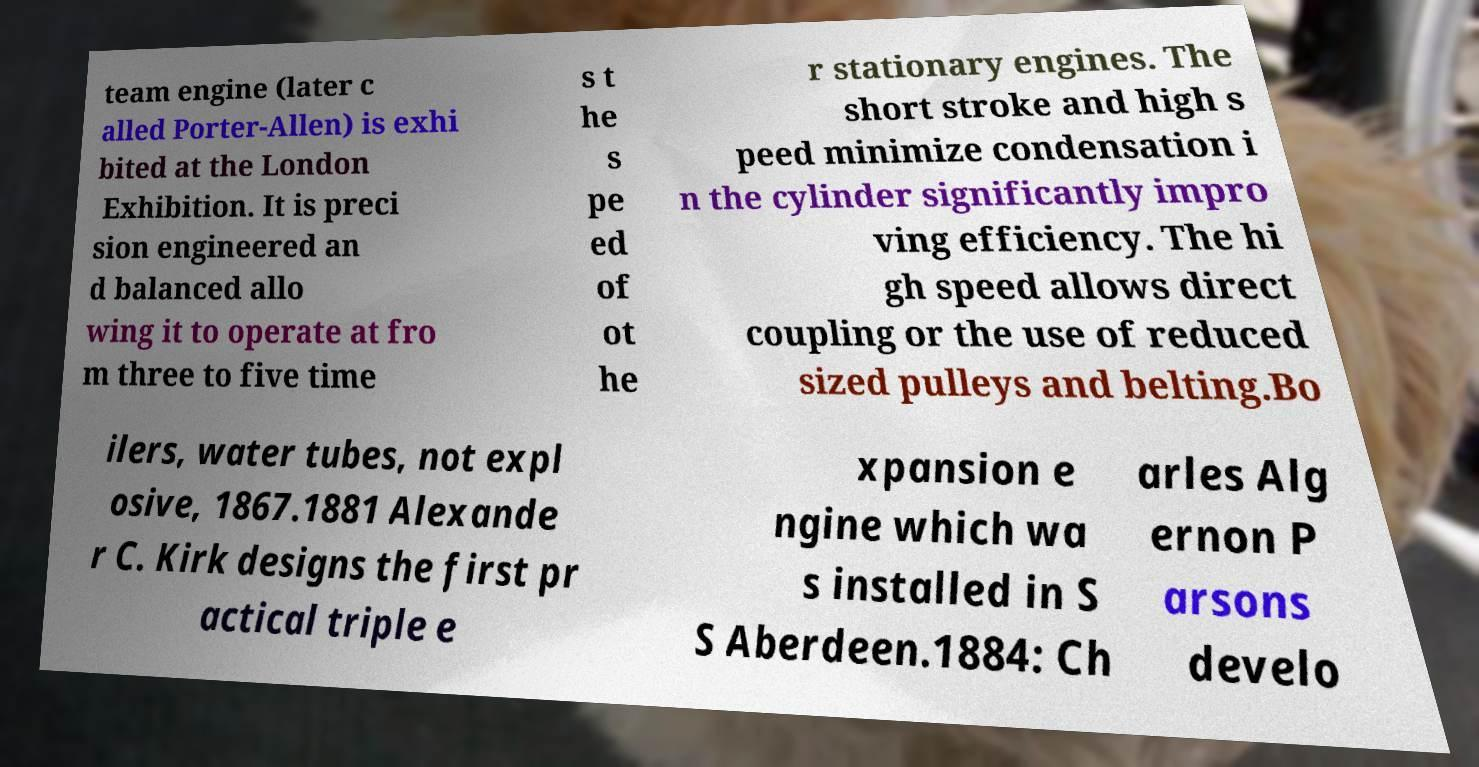Could you assist in decoding the text presented in this image and type it out clearly? team engine (later c alled Porter-Allen) is exhi bited at the London Exhibition. It is preci sion engineered an d balanced allo wing it to operate at fro m three to five time s t he s pe ed of ot he r stationary engines. The short stroke and high s peed minimize condensation i n the cylinder significantly impro ving efficiency. The hi gh speed allows direct coupling or the use of reduced sized pulleys and belting.Bo ilers, water tubes, not expl osive, 1867.1881 Alexande r C. Kirk designs the first pr actical triple e xpansion e ngine which wa s installed in S S Aberdeen.1884: Ch arles Alg ernon P arsons develo 